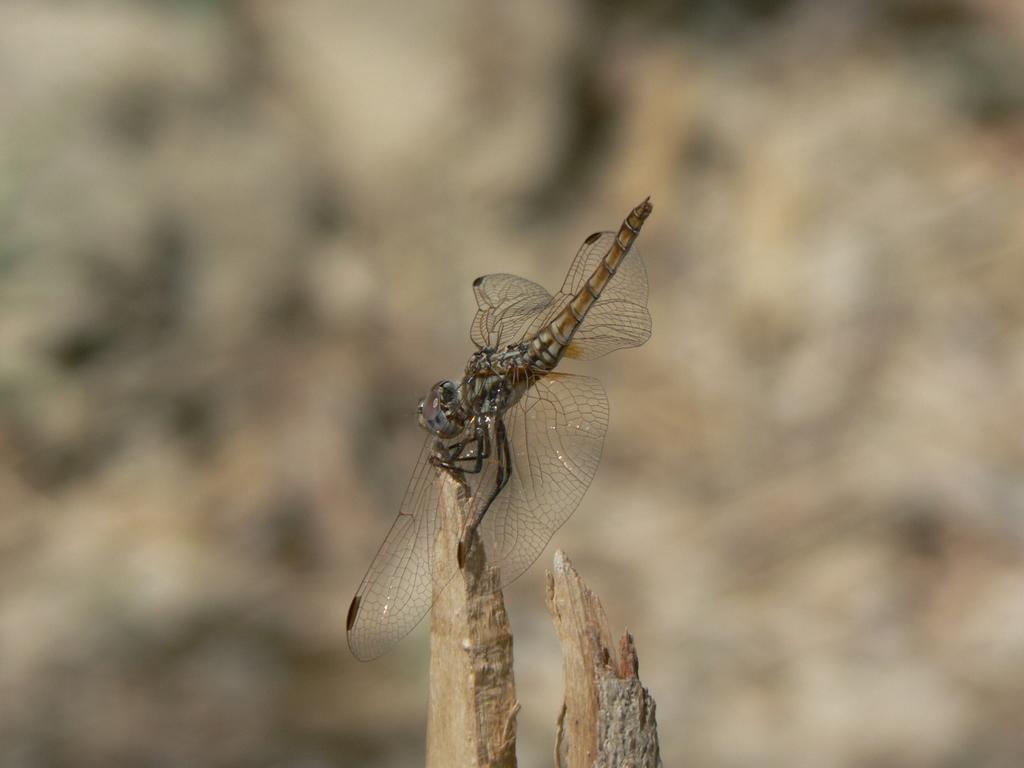In one or two sentences, can you explain what this image depicts? In the center of the image, we can see a fly on the wood and the background is blurry. 